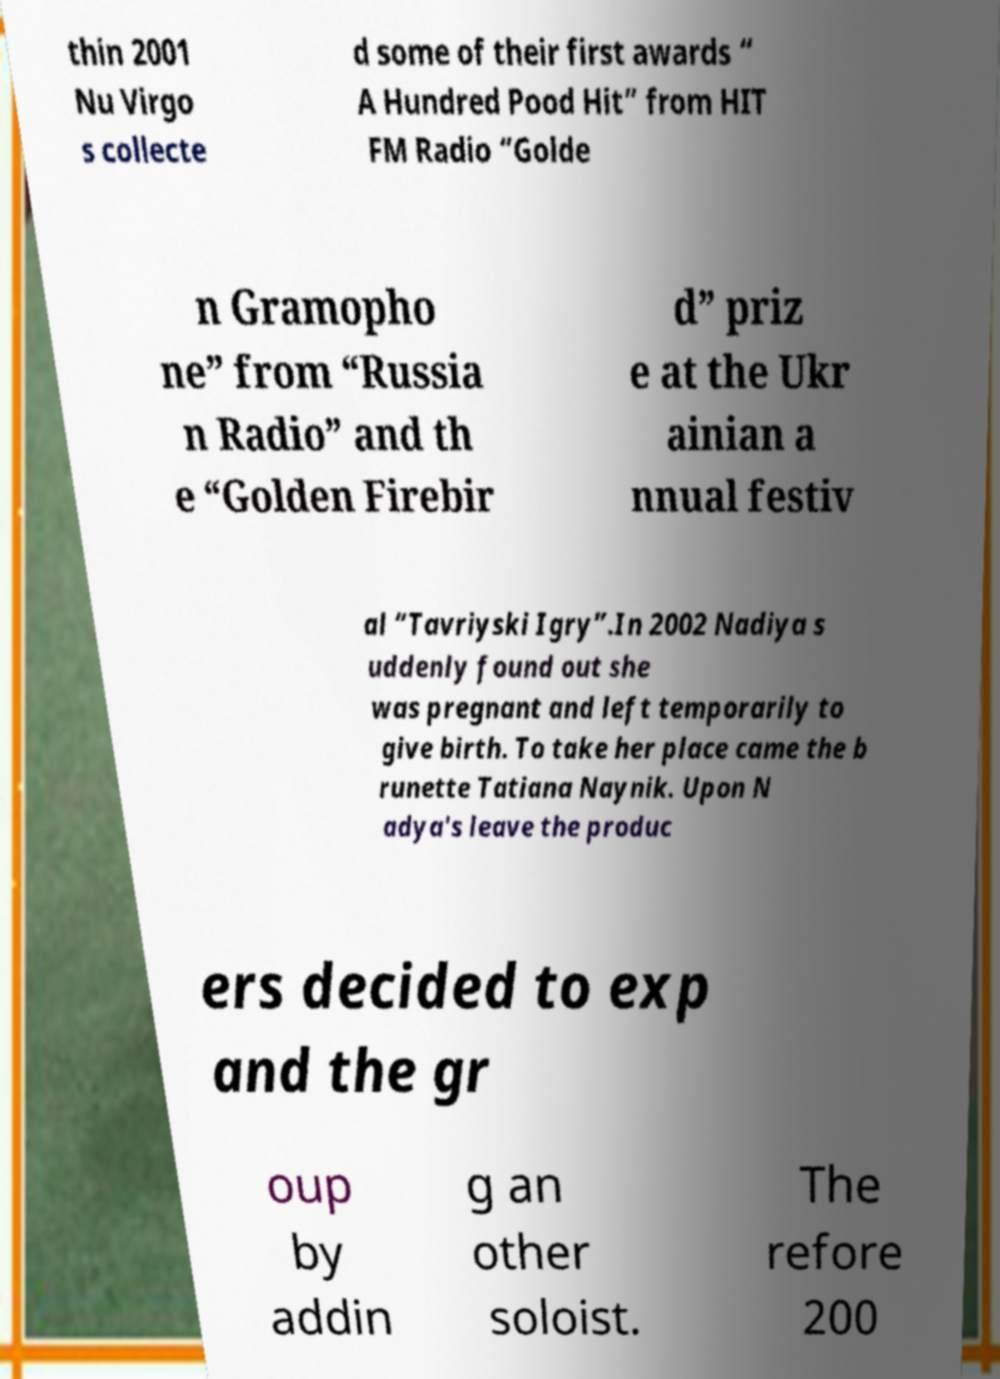Can you accurately transcribe the text from the provided image for me? thin 2001 Nu Virgo s collecte d some of their first awards “ A Hundred Pood Hit” from HIT FM Radio “Golde n Gramopho ne” from “Russia n Radio” and th e “Golden Firebir d” priz e at the Ukr ainian a nnual festiv al “Tavriyski Igry”.In 2002 Nadiya s uddenly found out she was pregnant and left temporarily to give birth. To take her place came the b runette Tatiana Naynik. Upon N adya's leave the produc ers decided to exp and the gr oup by addin g an other soloist. The refore 200 